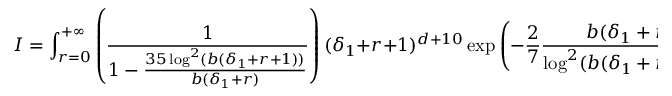Convert formula to latex. <formula><loc_0><loc_0><loc_500><loc_500>I = \int _ { r = 0 } ^ { + \infty } \left ( \frac { 1 } { 1 - \frac { 3 5 \log ^ { 2 } ( b ( \delta _ { 1 } + r + 1 ) ) } { b ( \delta _ { 1 } + r ) } } \right ) ( \delta _ { 1 } + r + 1 ) ^ { d + 1 0 } \exp \left ( - \frac { 2 } { 7 } \frac { b ( \delta _ { 1 } + r ) } { \log ^ { 2 } ( b ( \delta _ { 1 } + r + 1 ) ) } \right ) \, d r \leq c ^ { \prime } \epsilon .</formula> 